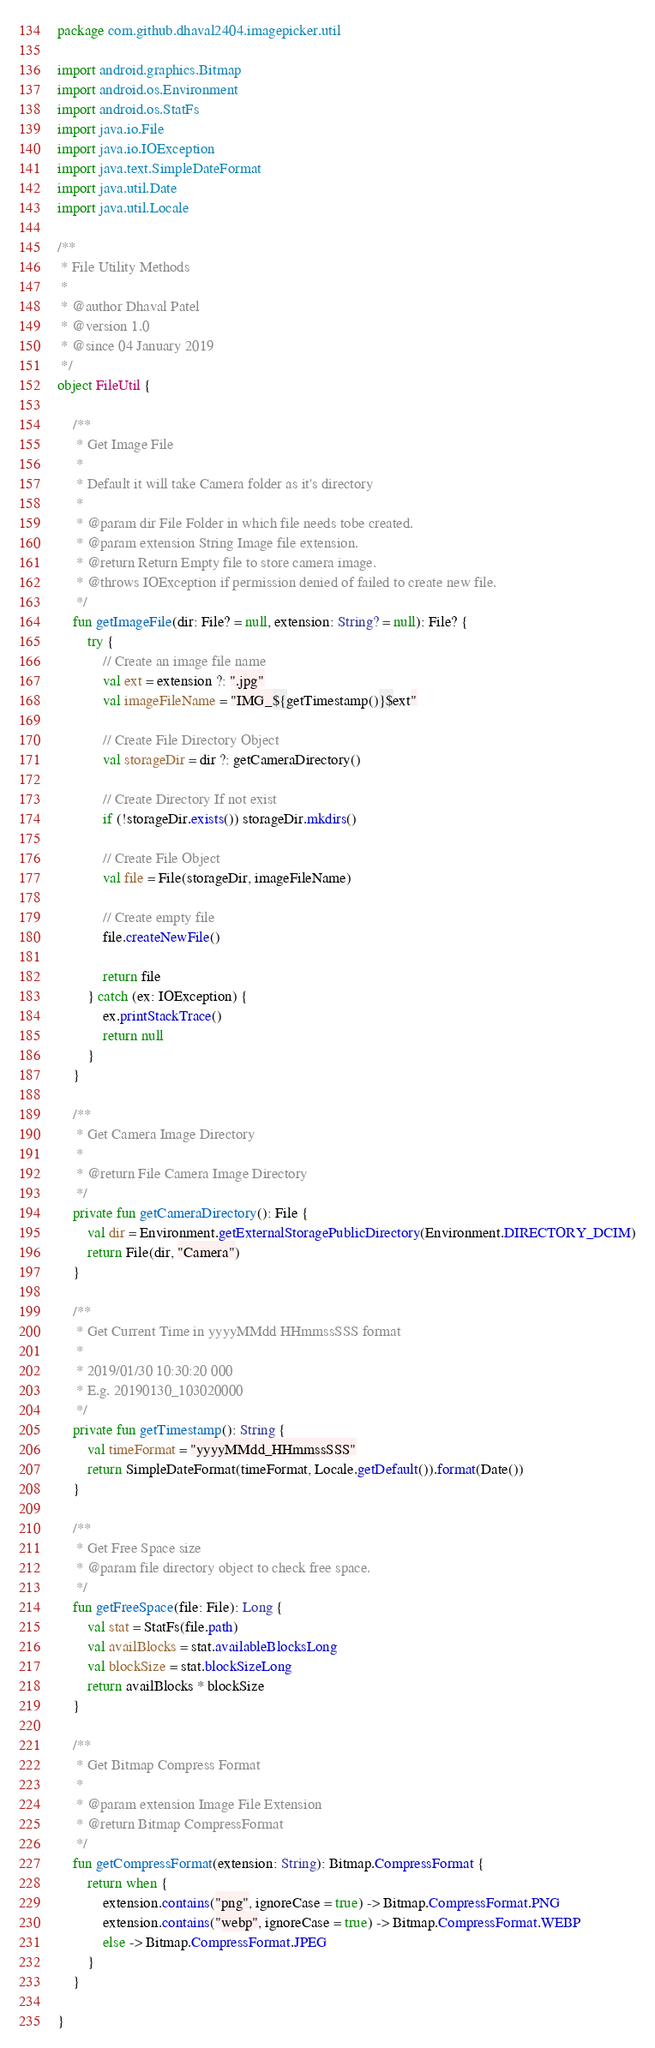Convert code to text. <code><loc_0><loc_0><loc_500><loc_500><_Kotlin_>package com.github.dhaval2404.imagepicker.util

import android.graphics.Bitmap
import android.os.Environment
import android.os.StatFs
import java.io.File
import java.io.IOException
import java.text.SimpleDateFormat
import java.util.Date
import java.util.Locale

/**
 * File Utility Methods
 *
 * @author Dhaval Patel
 * @version 1.0
 * @since 04 January 2019
 */
object FileUtil {

    /**
     * Get Image File
     *
     * Default it will take Camera folder as it's directory
     *
     * @param dir File Folder in which file needs tobe created.
     * @param extension String Image file extension.
     * @return Return Empty file to store camera image.
     * @throws IOException if permission denied of failed to create new file.
     */
    fun getImageFile(dir: File? = null, extension: String? = null): File? {
        try {
            // Create an image file name
            val ext = extension ?: ".jpg"
            val imageFileName = "IMG_${getTimestamp()}$ext"

            // Create File Directory Object
            val storageDir = dir ?: getCameraDirectory()

            // Create Directory If not exist
            if (!storageDir.exists()) storageDir.mkdirs()

            // Create File Object
            val file = File(storageDir, imageFileName)

            // Create empty file
            file.createNewFile()

            return file
        } catch (ex: IOException) {
            ex.printStackTrace()
            return null
        }
    }

    /**
     * Get Camera Image Directory
     *
     * @return File Camera Image Directory
     */
    private fun getCameraDirectory(): File {
        val dir = Environment.getExternalStoragePublicDirectory(Environment.DIRECTORY_DCIM)
        return File(dir, "Camera")
    }

    /**
     * Get Current Time in yyyyMMdd HHmmssSSS format
     *
     * 2019/01/30 10:30:20 000
     * E.g. 20190130_103020000
     */
    private fun getTimestamp(): String {
        val timeFormat = "yyyyMMdd_HHmmssSSS"
        return SimpleDateFormat(timeFormat, Locale.getDefault()).format(Date())
    }

    /**
     * Get Free Space size
     * @param file directory object to check free space.
     */
    fun getFreeSpace(file: File): Long {
        val stat = StatFs(file.path)
        val availBlocks = stat.availableBlocksLong
        val blockSize = stat.blockSizeLong
        return availBlocks * blockSize
    }

    /**
     * Get Bitmap Compress Format
     *
     * @param extension Image File Extension
     * @return Bitmap CompressFormat
     */
    fun getCompressFormat(extension: String): Bitmap.CompressFormat {
        return when {
            extension.contains("png", ignoreCase = true) -> Bitmap.CompressFormat.PNG
            extension.contains("webp", ignoreCase = true) -> Bitmap.CompressFormat.WEBP
            else -> Bitmap.CompressFormat.JPEG
        }
    }

}
</code> 